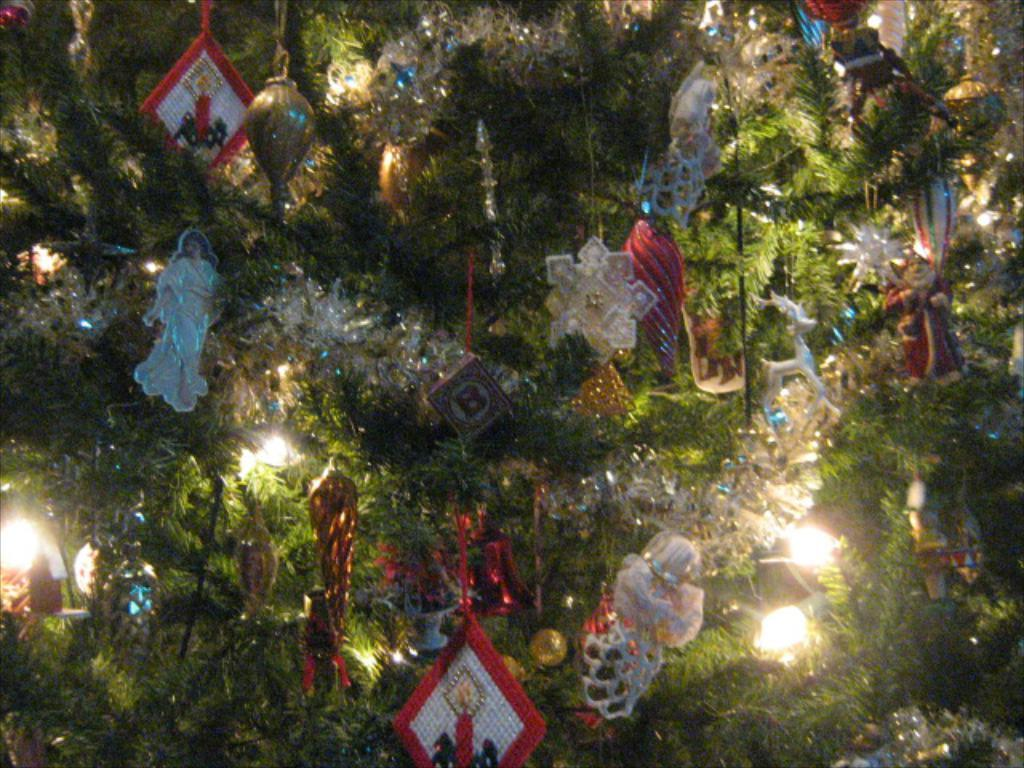What is the main object in the image? There is a Christmas tree in the image. What can be seen on the Christmas tree? The Christmas tree has decorative items, lights, toys, and balls hanging on it. Can you see any ghosts interacting with the Christmas tree in the image? There are no ghosts present in the image. What type of brain is hanging on the Christmas tree? There are no brains present in the image; the decorations include toys and balls. 